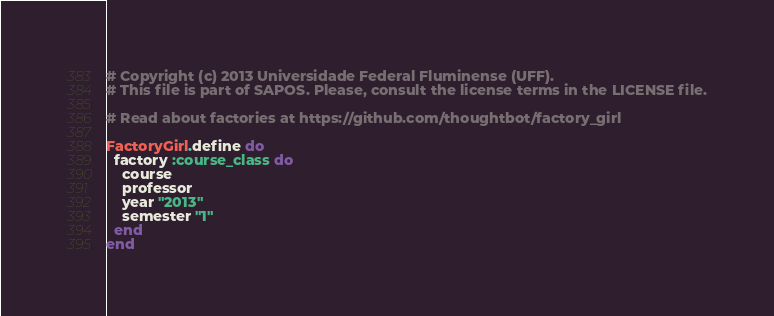Convert code to text. <code><loc_0><loc_0><loc_500><loc_500><_Ruby_># Copyright (c) 2013 Universidade Federal Fluminense (UFF).
# This file is part of SAPOS. Please, consult the license terms in the LICENSE file.

# Read about factories at https://github.com/thoughtbot/factory_girl

FactoryGirl.define do
  factory :course_class do
    course
    professor
    year "2013"
    semester "1"
  end
end
</code> 